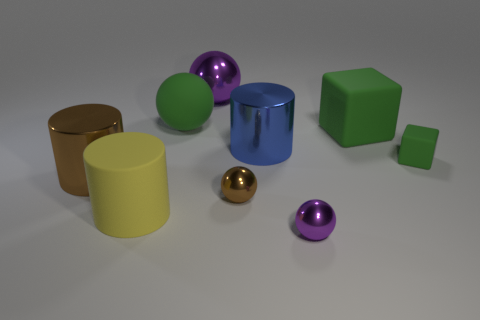What shape is the large purple object that is the same material as the small purple ball?
Ensure brevity in your answer.  Sphere. Do the rubber sphere and the yellow object have the same size?
Provide a short and direct response. Yes. Do the yellow cylinder that is to the left of the tiny brown object and the tiny purple ball have the same material?
Make the answer very short. No. Are there any other things that have the same material as the large blue cylinder?
Keep it short and to the point. Yes. How many large green rubber blocks are in front of the metallic cylinder that is right of the purple metallic thing to the left of the big blue cylinder?
Ensure brevity in your answer.  0. There is a large rubber thing that is in front of the large brown metal cylinder; does it have the same shape as the small brown metallic object?
Ensure brevity in your answer.  No. How many things are either tiny yellow shiny things or large blue metallic things that are on the right side of the big purple shiny sphere?
Ensure brevity in your answer.  1. Are there more yellow things on the right side of the small purple ball than small brown things?
Provide a short and direct response. No. Are there the same number of tiny purple metal balls that are on the left side of the large purple thing and matte cylinders in front of the tiny matte thing?
Provide a short and direct response. No. There is a brown metallic thing that is left of the green sphere; are there any rubber cylinders that are behind it?
Provide a succinct answer. No. 